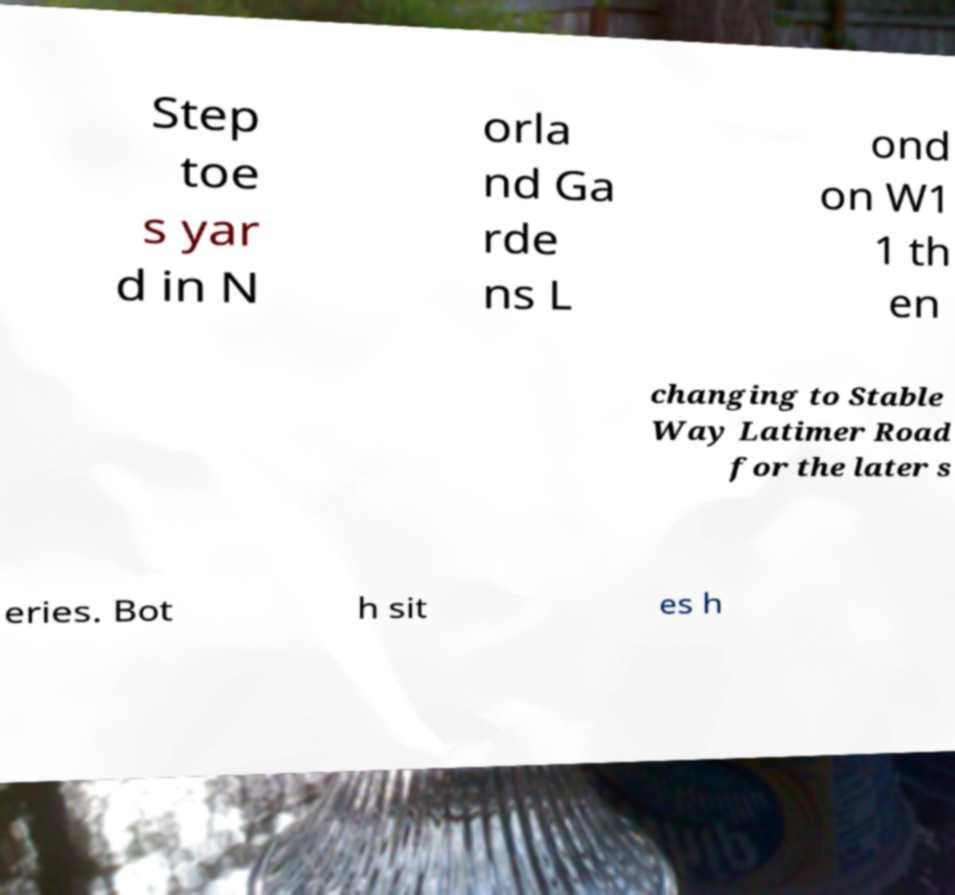Can you read and provide the text displayed in the image?This photo seems to have some interesting text. Can you extract and type it out for me? Step toe s yar d in N orla nd Ga rde ns L ond on W1 1 th en changing to Stable Way Latimer Road for the later s eries. Bot h sit es h 